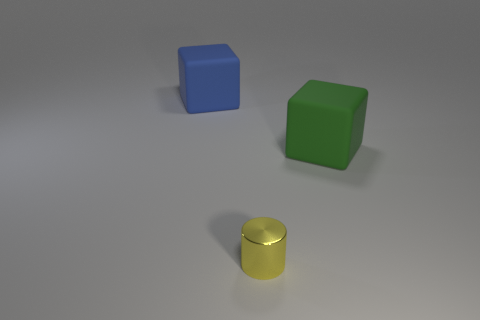Subtract all green blocks. How many blocks are left? 1 Subtract 0 gray blocks. How many objects are left? 3 Subtract all cylinders. How many objects are left? 2 Subtract 1 blocks. How many blocks are left? 1 Subtract all blue cubes. Subtract all green cylinders. How many cubes are left? 1 Subtract all blue cylinders. How many blue blocks are left? 1 Subtract all blue metallic objects. Subtract all large cubes. How many objects are left? 1 Add 3 yellow shiny cylinders. How many yellow shiny cylinders are left? 4 Add 2 big objects. How many big objects exist? 4 Add 1 big green matte blocks. How many objects exist? 4 